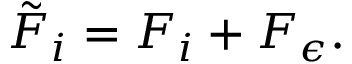Convert formula to latex. <formula><loc_0><loc_0><loc_500><loc_500>\tilde { F } _ { i } = F _ { i } + F _ { \epsilon } .</formula> 